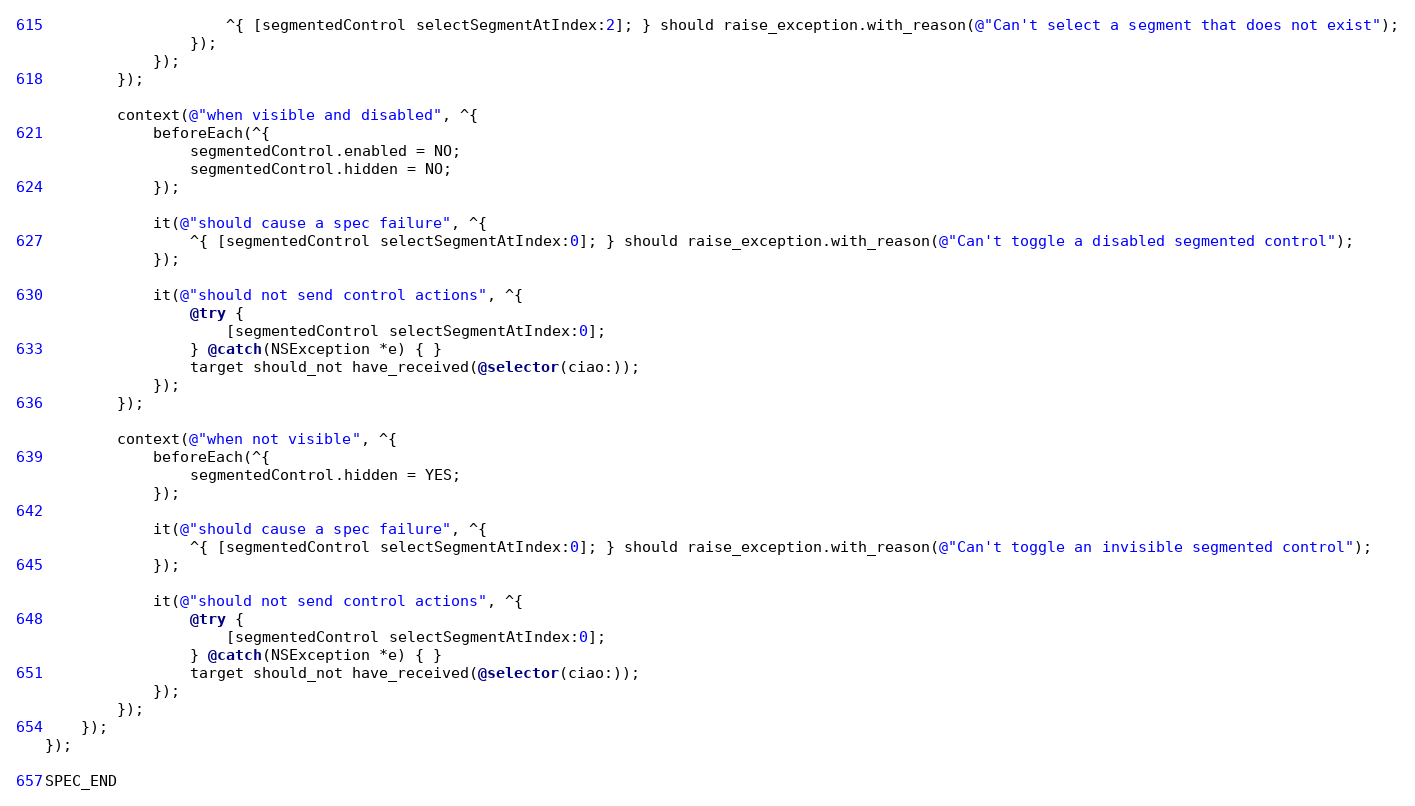Convert code to text. <code><loc_0><loc_0><loc_500><loc_500><_ObjectiveC_>                    ^{ [segmentedControl selectSegmentAtIndex:2]; } should raise_exception.with_reason(@"Can't select a segment that does not exist");
                });
            });
        });

        context(@"when visible and disabled", ^{
            beforeEach(^{
                segmentedControl.enabled = NO;
                segmentedControl.hidden = NO;
            });

            it(@"should cause a spec failure", ^{
                ^{ [segmentedControl selectSegmentAtIndex:0]; } should raise_exception.with_reason(@"Can't toggle a disabled segmented control");
            });

            it(@"should not send control actions", ^{
                @try {
                    [segmentedControl selectSegmentAtIndex:0];
                } @catch(NSException *e) { }
                target should_not have_received(@selector(ciao:));
            });
        });

        context(@"when not visible", ^{
            beforeEach(^{
                segmentedControl.hidden = YES;
            });

            it(@"should cause a spec failure", ^{
                ^{ [segmentedControl selectSegmentAtIndex:0]; } should raise_exception.with_reason(@"Can't toggle an invisible segmented control");
            });

            it(@"should not send control actions", ^{
                @try {
                    [segmentedControl selectSegmentAtIndex:0];
                } @catch(NSException *e) { }
                target should_not have_received(@selector(ciao:));
            });
        });
    });
});

SPEC_END
</code> 